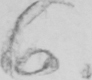Please transcribe the handwritten text in this image. 6 . 